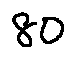<formula> <loc_0><loc_0><loc_500><loc_500>8 0</formula> 